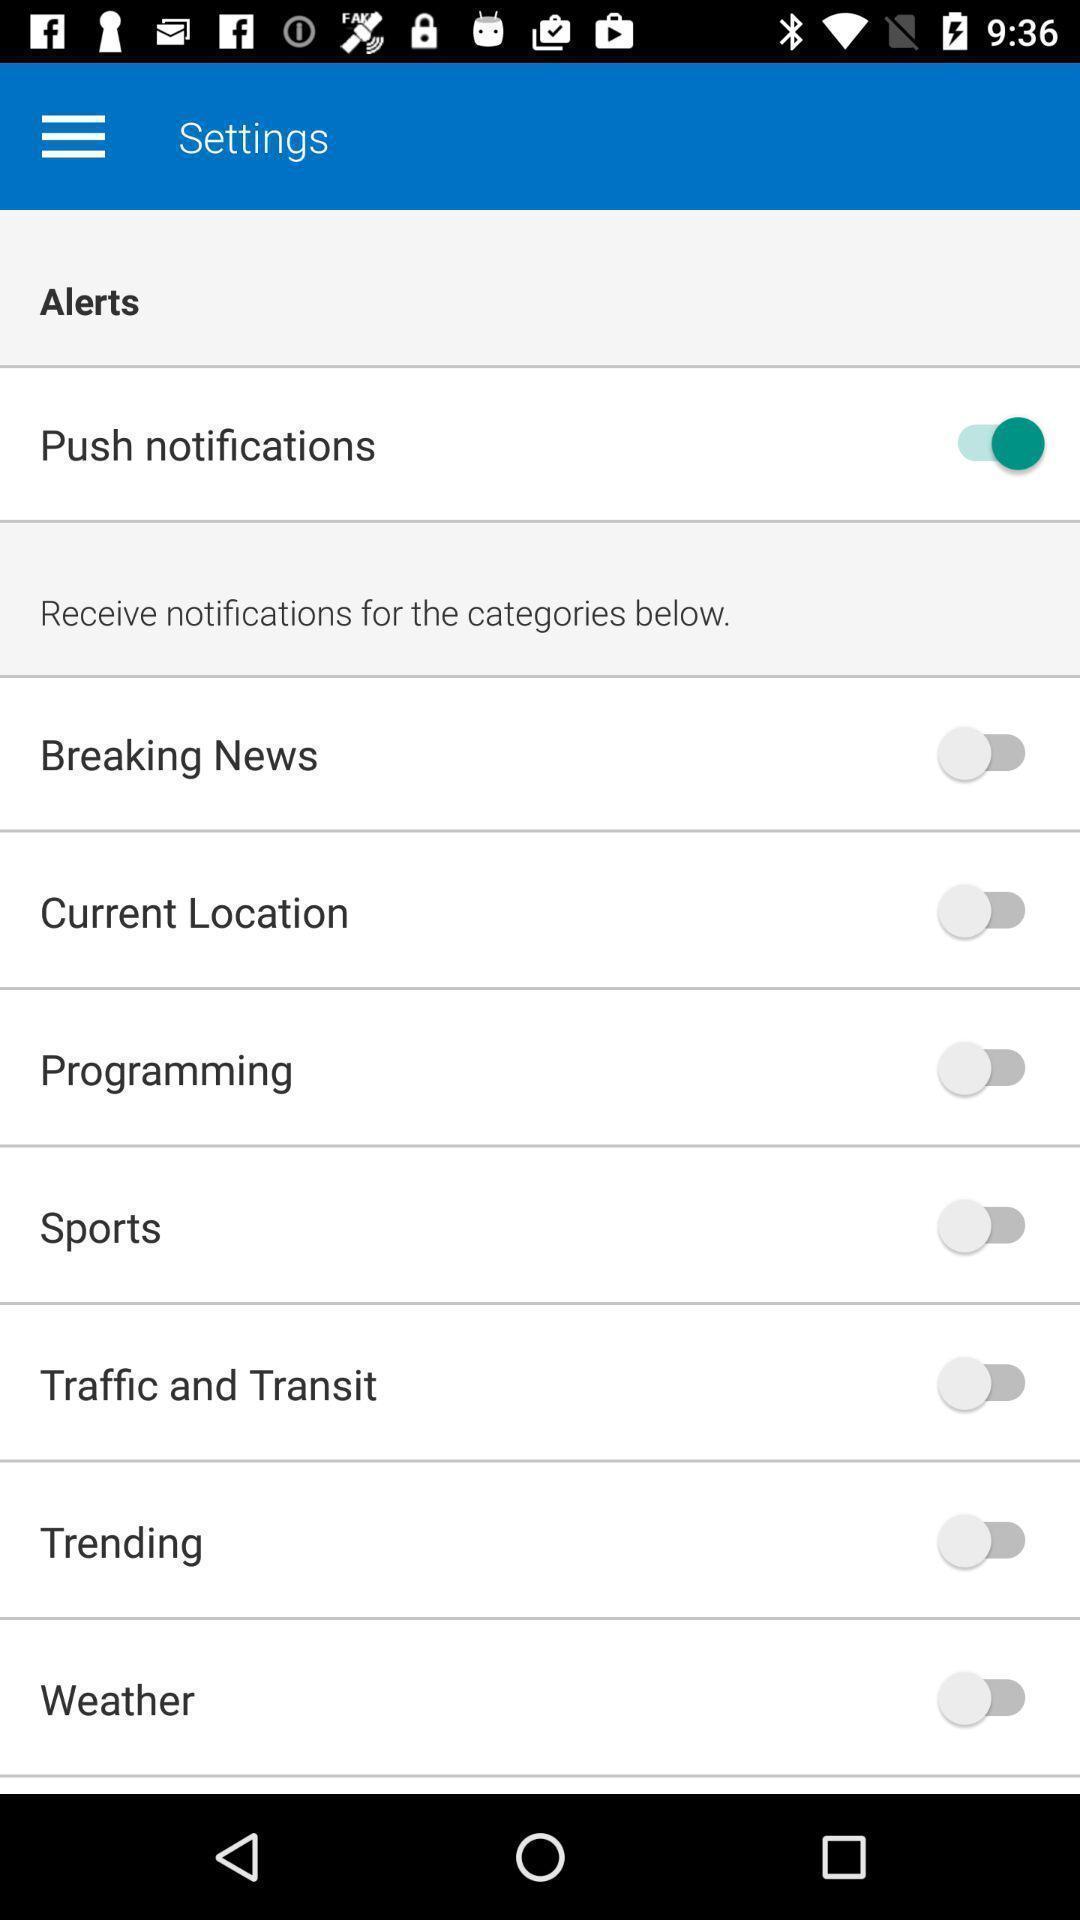Please provide a description for this image. Settings page. 